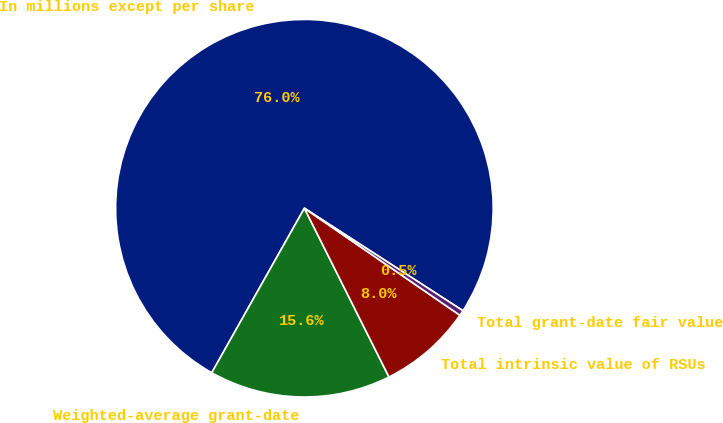Convert chart. <chart><loc_0><loc_0><loc_500><loc_500><pie_chart><fcel>In millions except per share<fcel>Weighted-average grant-date<fcel>Total intrinsic value of RSUs<fcel>Total grant-date fair value of<nl><fcel>75.98%<fcel>15.56%<fcel>8.01%<fcel>0.46%<nl></chart> 